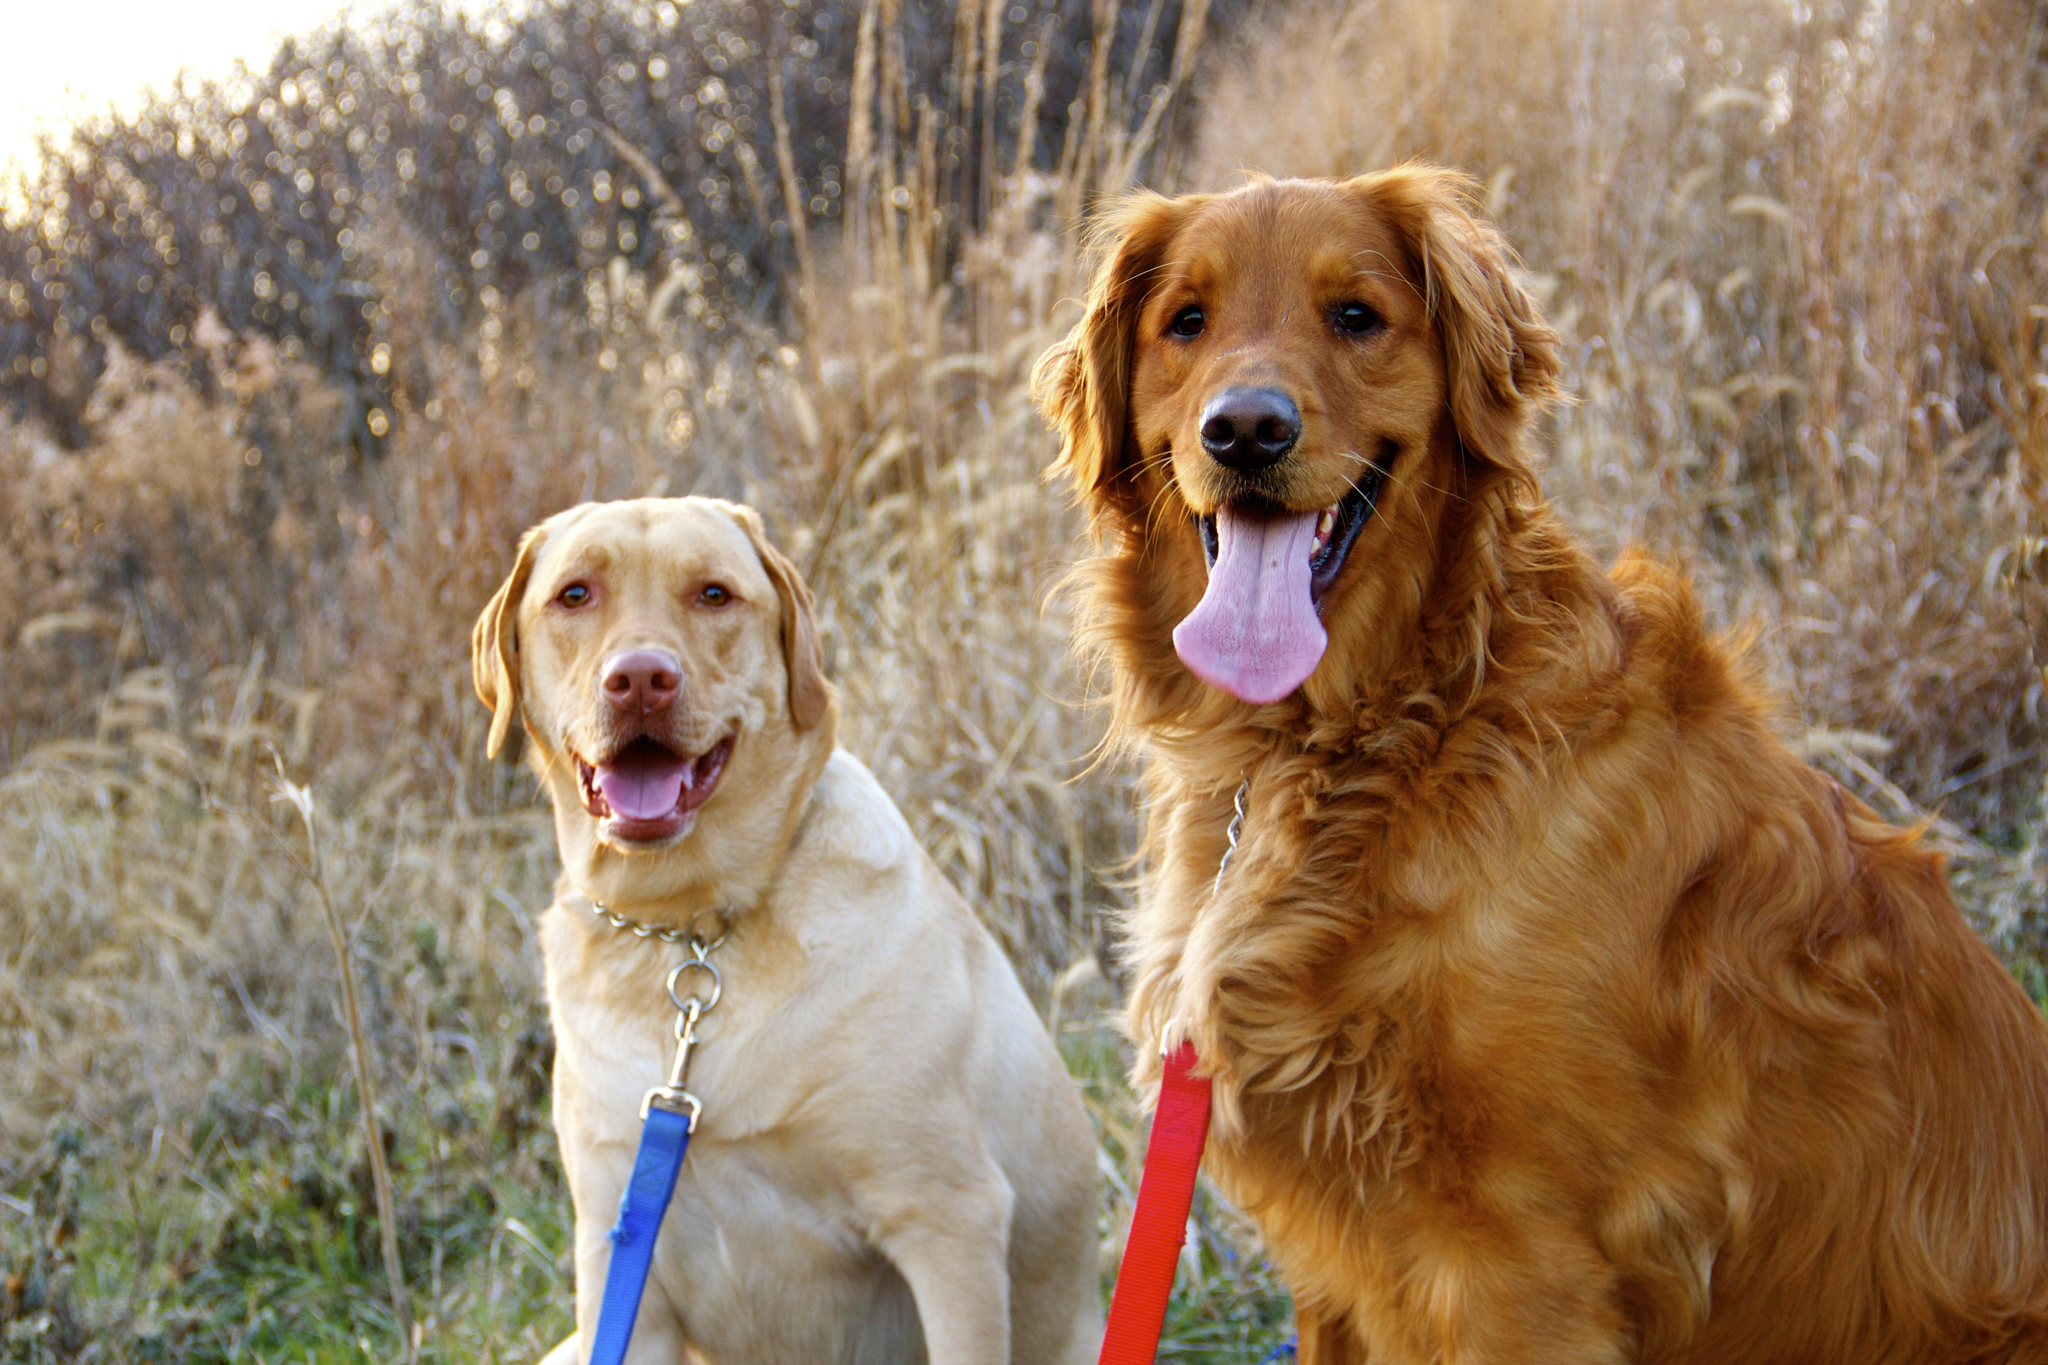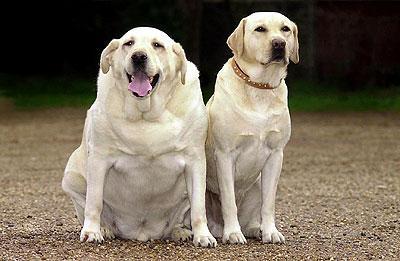The first image is the image on the left, the second image is the image on the right. Assess this claim about the two images: "Both images contain exactly three dogs, and include at least one image of all different colored dogs.". Correct or not? Answer yes or no. No. The first image is the image on the left, the second image is the image on the right. Given the left and right images, does the statement "There are three labs posing together in each image." hold true? Answer yes or no. No. 